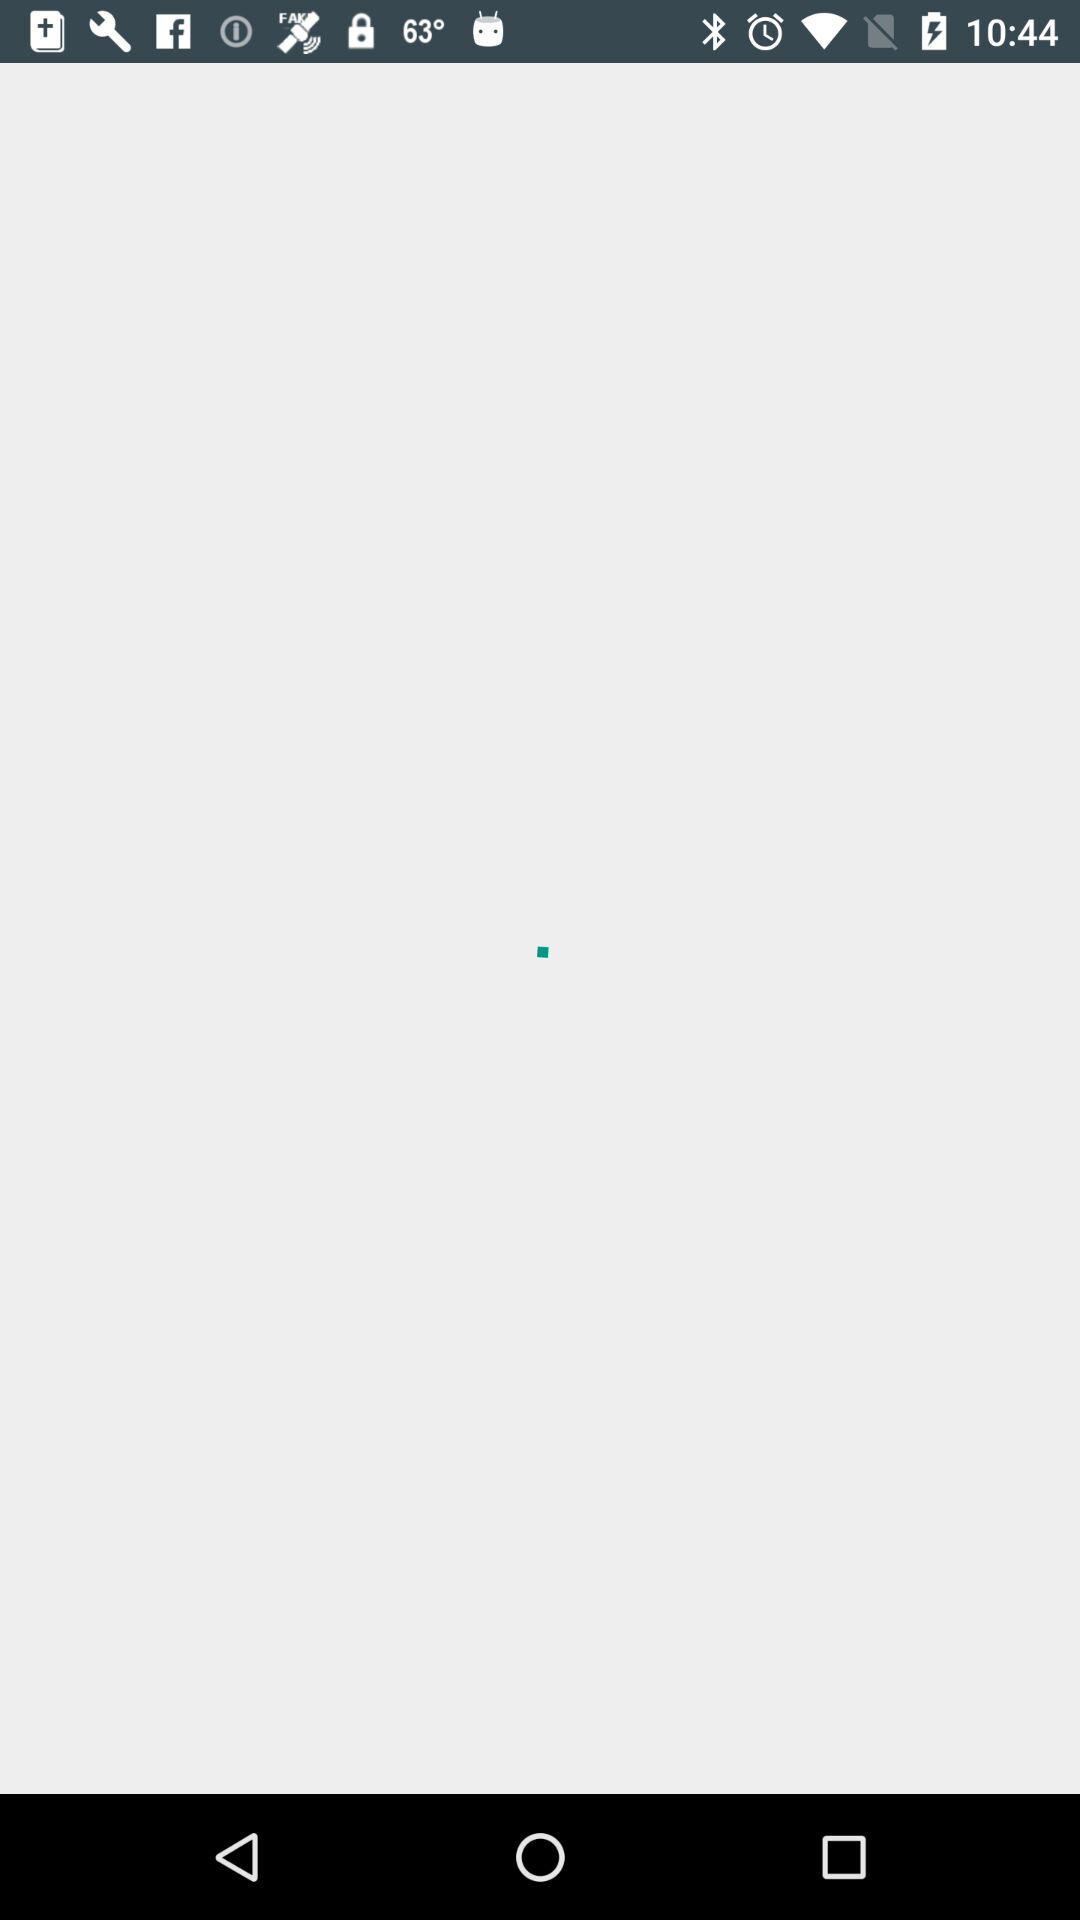What are the different car brands? The different car brands are "Buick", "Cadillac", "Chevrolet", "Chrysler", "Citroen", "Dacia", "Daihatsu", "Dodge", "Fiat", "Ford", "GMC" and "Honda". 